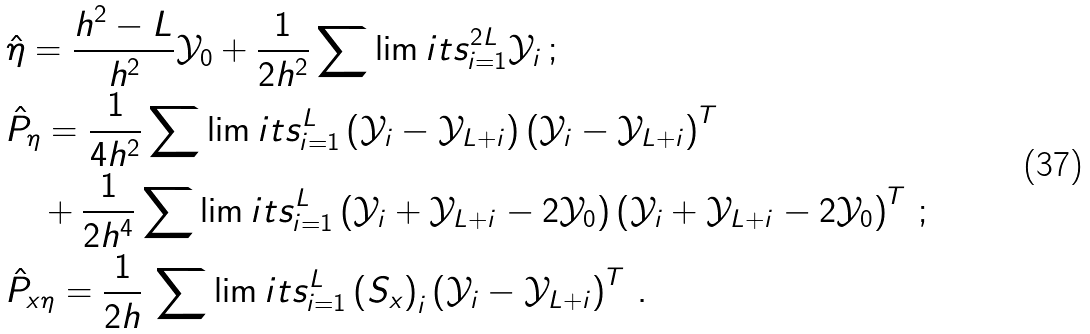<formula> <loc_0><loc_0><loc_500><loc_500>& \hat { \eta } = \frac { h ^ { 2 } - L } { h ^ { 2 } } \mathcal { Y } _ { 0 } + \frac { 1 } { 2 h ^ { 2 } } \sum \lim i t s _ { i = 1 } ^ { 2 L } \mathcal { Y } _ { i } \, ; \\ & \hat { P } _ { \eta } = \frac { 1 } { 4 h ^ { 2 } } \sum \lim i t s _ { i = 1 } ^ { L } \left ( \mathcal { Y } _ { i } - \mathcal { Y } _ { L + i } \right ) \left ( \mathcal { Y } _ { i } - \mathcal { Y } _ { L + i } \right ) ^ { T } \\ & \quad + \frac { 1 } { 2 h ^ { 4 } } \sum \lim i t s _ { i = 1 } ^ { L } \left ( \mathcal { Y } _ { i } + \mathcal { Y } _ { L + i } - 2 \mathcal { Y } _ { 0 } \right ) \left ( \mathcal { Y } _ { i } + \mathcal { Y } _ { L + i } - 2 \mathcal { Y } _ { 0 } \right ) ^ { T } \, ; \\ & \hat { P } _ { x \eta } = \frac { 1 } { 2 h } \, \sum \lim i t s _ { i = 1 } ^ { L } \left ( S _ { x } \right ) _ { i } \left ( \mathcal { Y } _ { i } - \mathcal { Y } _ { L + i } \right ) ^ { T } \, .</formula> 